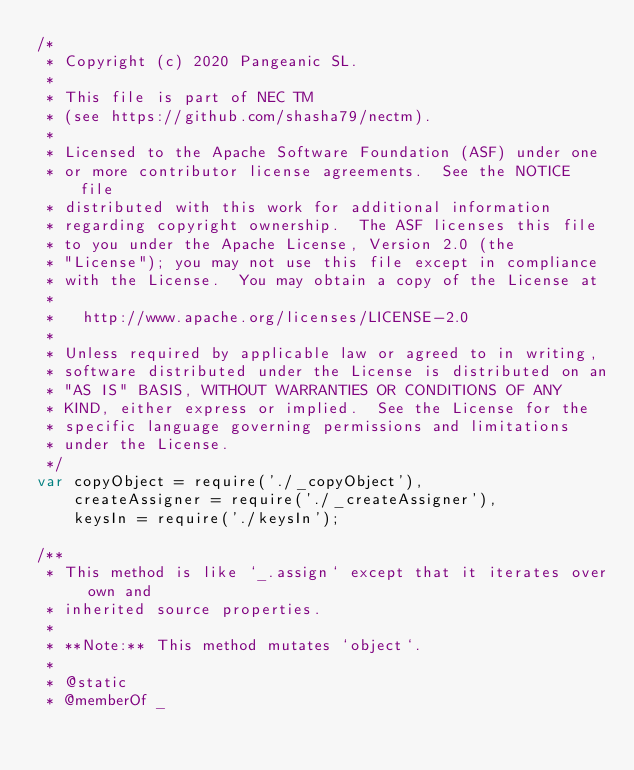Convert code to text. <code><loc_0><loc_0><loc_500><loc_500><_JavaScript_>/*
 * Copyright (c) 2020 Pangeanic SL.
 *
 * This file is part of NEC TM
 * (see https://github.com/shasha79/nectm).
 *
 * Licensed to the Apache Software Foundation (ASF) under one
 * or more contributor license agreements.  See the NOTICE file
 * distributed with this work for additional information
 * regarding copyright ownership.  The ASF licenses this file
 * to you under the Apache License, Version 2.0 (the
 * "License"); you may not use this file except in compliance
 * with the License.  You may obtain a copy of the License at
 *
 *   http://www.apache.org/licenses/LICENSE-2.0
 *
 * Unless required by applicable law or agreed to in writing,
 * software distributed under the License is distributed on an
 * "AS IS" BASIS, WITHOUT WARRANTIES OR CONDITIONS OF ANY
 * KIND, either express or implied.  See the License for the
 * specific language governing permissions and limitations
 * under the License.
 */
var copyObject = require('./_copyObject'),
    createAssigner = require('./_createAssigner'),
    keysIn = require('./keysIn');

/**
 * This method is like `_.assign` except that it iterates over own and
 * inherited source properties.
 *
 * **Note:** This method mutates `object`.
 *
 * @static
 * @memberOf _</code> 